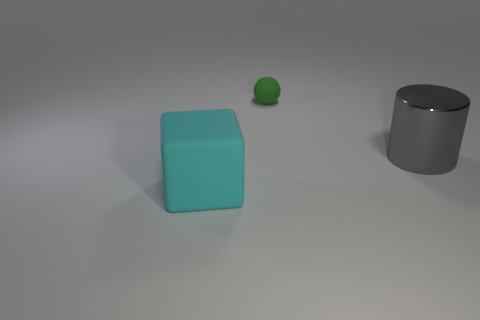What is the shape of the gray metal thing that is the same size as the cyan block? The gray metal object is a cylinder, which appears roughly the same size in height as the cyan-colored cube next to it. Its reflective surface and circular top indicate its cylindrical shape, distinguishing it from the cube's square edges and flat surfaces. 